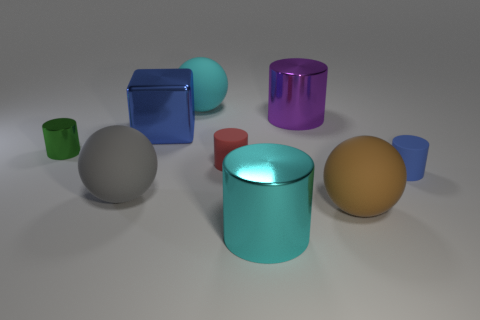Can you describe the lighting in the scene? The scene is softly lit from above, creating gentle shadows beneath the objects and highlighting their shapes and colors. There's no harsh lighting, which provides a smooth appearance to the objects. 